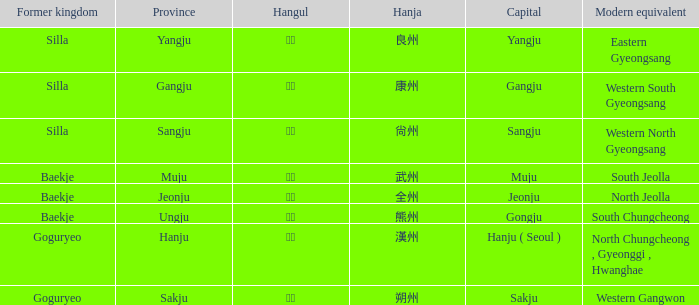The hanja 朔州 is for what province? Sakju. 